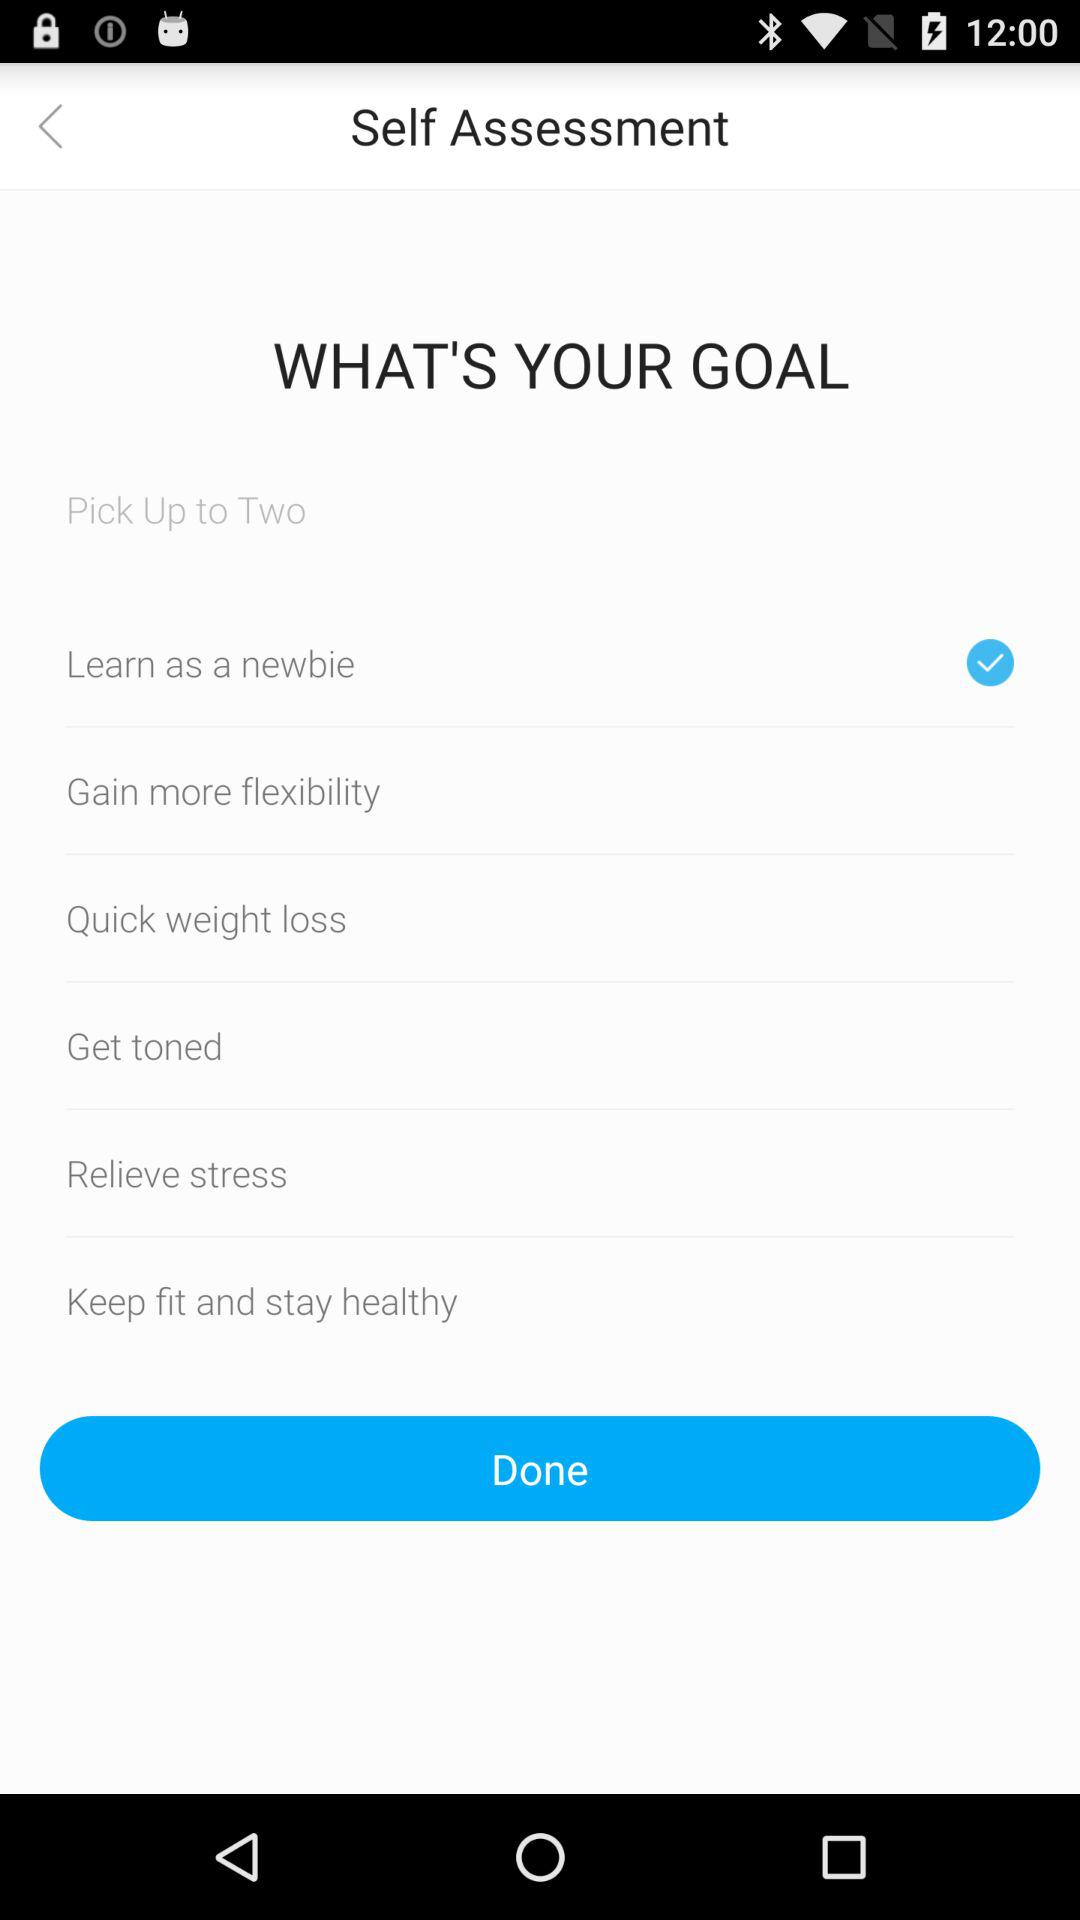How many goals can be picked up? The goals that can be picked are up to two. 